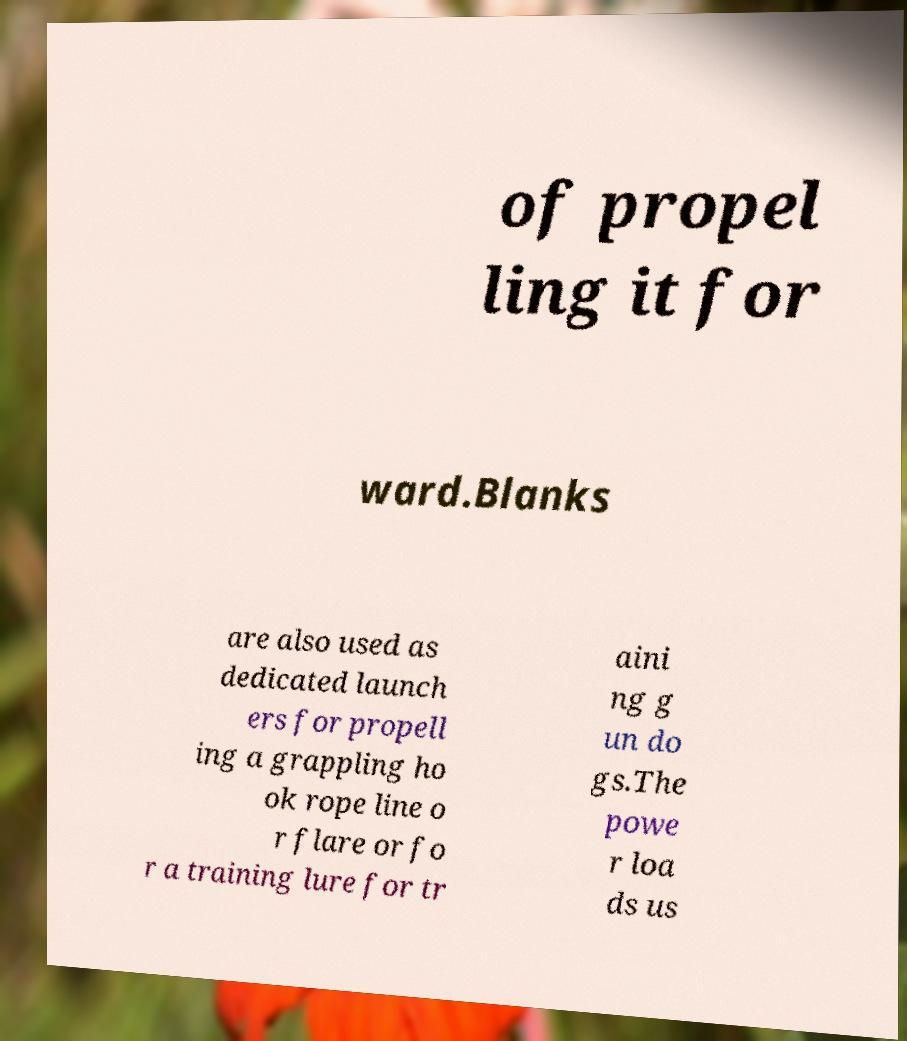I need the written content from this picture converted into text. Can you do that? of propel ling it for ward.Blanks are also used as dedicated launch ers for propell ing a grappling ho ok rope line o r flare or fo r a training lure for tr aini ng g un do gs.The powe r loa ds us 